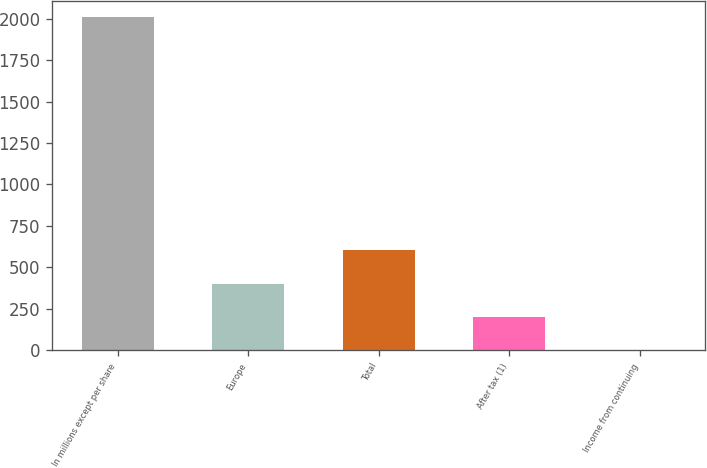Convert chart. <chart><loc_0><loc_0><loc_500><loc_500><bar_chart><fcel>In millions except per share<fcel>Europe<fcel>Total<fcel>After tax (1)<fcel>Income from continuing<nl><fcel>2008<fcel>401.61<fcel>602.41<fcel>200.81<fcel>0.01<nl></chart> 